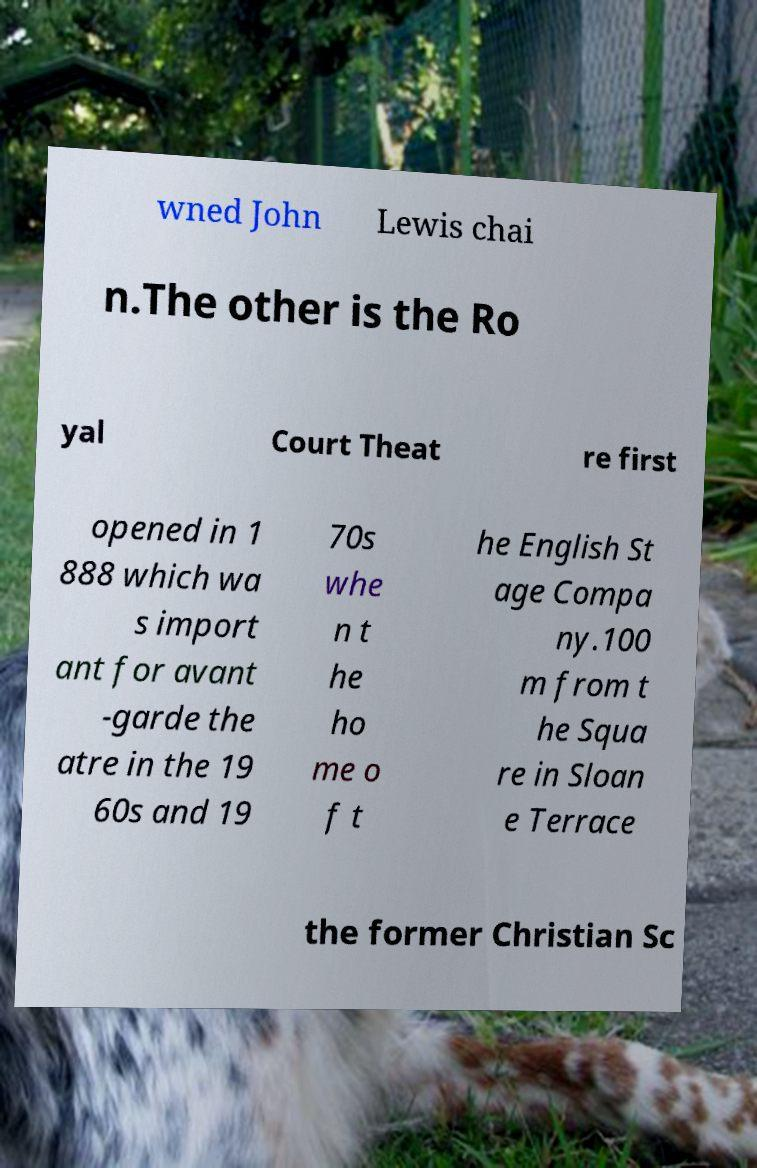I need the written content from this picture converted into text. Can you do that? wned John Lewis chai n.The other is the Ro yal Court Theat re first opened in 1 888 which wa s import ant for avant -garde the atre in the 19 60s and 19 70s whe n t he ho me o f t he English St age Compa ny.100 m from t he Squa re in Sloan e Terrace the former Christian Sc 